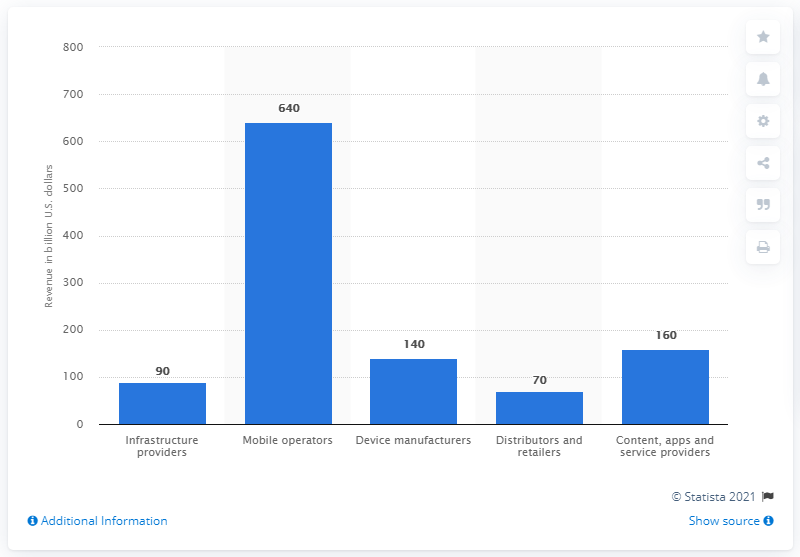Outline some significant characteristics in this image. In 2019, content, apps, and service providers collectively contributed approximately 160 to the mobile ecosystem. In 2019, the mobile operators segment contributed approximately $640 to the mobile ecosystem. 